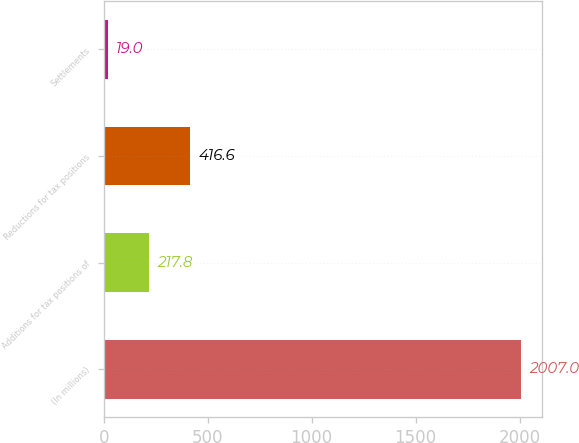Convert chart to OTSL. <chart><loc_0><loc_0><loc_500><loc_500><bar_chart><fcel>(In millions)<fcel>Additions for tax positions of<fcel>Reductions for tax positions<fcel>Settlements<nl><fcel>2007<fcel>217.8<fcel>416.6<fcel>19<nl></chart> 